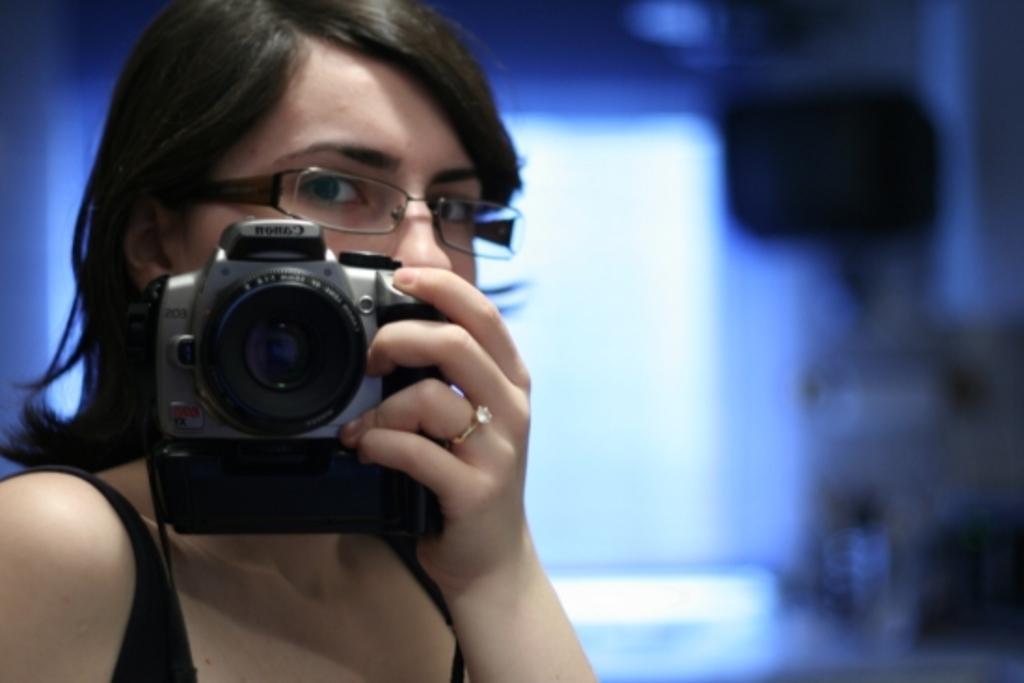Please provide a concise description of this image. In this picture, we see woman holding camera in her hands and she's even wearing spectacles. Behind her, we see a blue wall and she is wearing black t-shirt. 